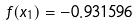<formula> <loc_0><loc_0><loc_500><loc_500>f ( x _ { 1 } ) = - 0 . 9 3 1 5 9 6</formula> 